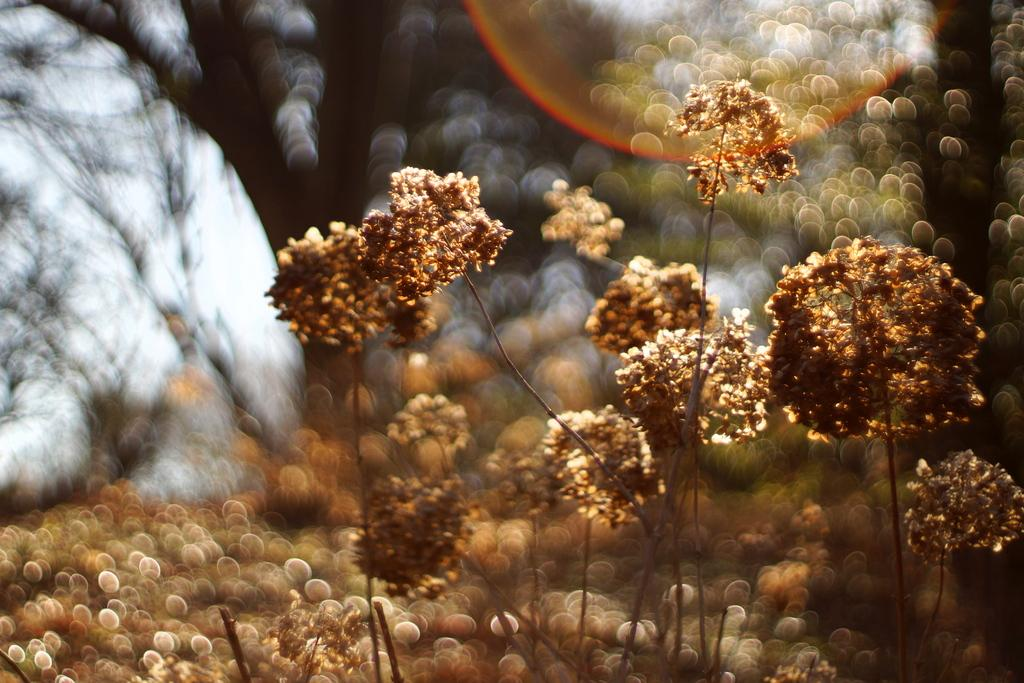What is located in the front of the image? There are plants in the front of the image. Can you describe the background of the image? The background of the image is blurry. How many pets can be seen playing with the crow in the image? There is no crow or pets present in the image. What type of fan is visible in the image? There is no fan present in the image. 